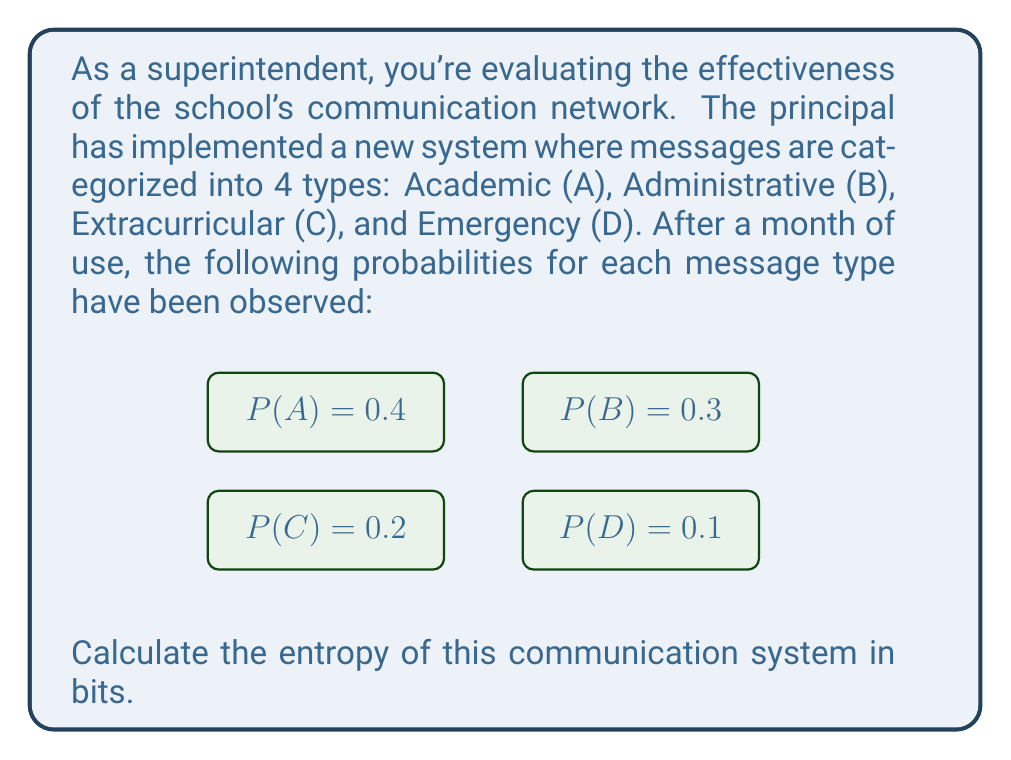What is the answer to this math problem? To calculate the entropy of the communication system, we'll use the formula for Shannon entropy:

$$ H = -\sum_{i=1}^n p_i \log_2(p_i) $$

Where $p_i$ is the probability of each message type, and $n$ is the number of message types.

Step 1: Calculate each term in the summation:
- For A: $-0.4 \log_2(0.4) = 0.528321$
- For B: $-0.3 \log_2(0.3) = 0.521478$
- For C: $-0.2 \log_2(0.2) = 0.464386$
- For D: $-0.1 \log_2(0.1) = 0.332193$

Step 2: Sum all the terms:
$$ H = 0.528321 + 0.521478 + 0.464386 + 0.332193 $$

Step 3: Calculate the final result:
$$ H = 1.846378 \text{ bits} $$

This entropy value indicates the average amount of information conveyed by each message in the school's communication system.
Answer: 1.846378 bits 